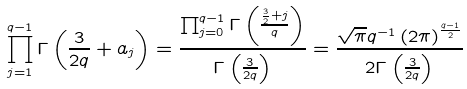Convert formula to latex. <formula><loc_0><loc_0><loc_500><loc_500>\prod _ { j = 1 } ^ { q - 1 } \Gamma \left ( \frac { 3 } { 2 q } + a _ { j } \right ) = \frac { \prod _ { j = 0 } ^ { q - 1 } \Gamma \left ( \frac { \frac { 3 } { 2 } + j } { q } \right ) } { \Gamma \left ( \frac { 3 } { 2 q } \right ) } = \frac { \sqrt { \pi } q ^ { - 1 } \left ( 2 \pi \right ) ^ { \frac { q - 1 } { 2 } } } { 2 \Gamma \left ( \frac { 3 } { 2 q } \right ) }</formula> 